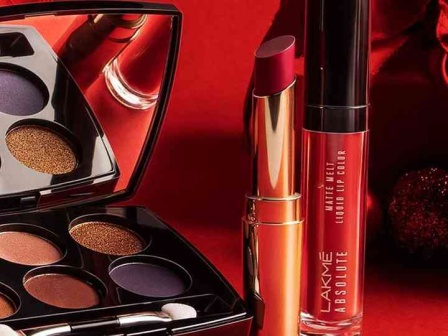What are the key elements in this picture? The image prominently features three products from the Lakme Absolute collection. In the center is an eyeshadow palette with the lid open, showing six shades evenly split between shimmering golds and varied purples. To the right, a lipstick in a luxurious metallic gold casing draws attention, its cap removed to display an enticing shade. Completing the trio is a liquid lip color to the left, in a captivating deep red, housed in a sleek tube. Each product is carefully positioned against a rich red background that amplifies the visual impact of the colors, invoking a sense of luxury and style suitable for various makeup needs. 